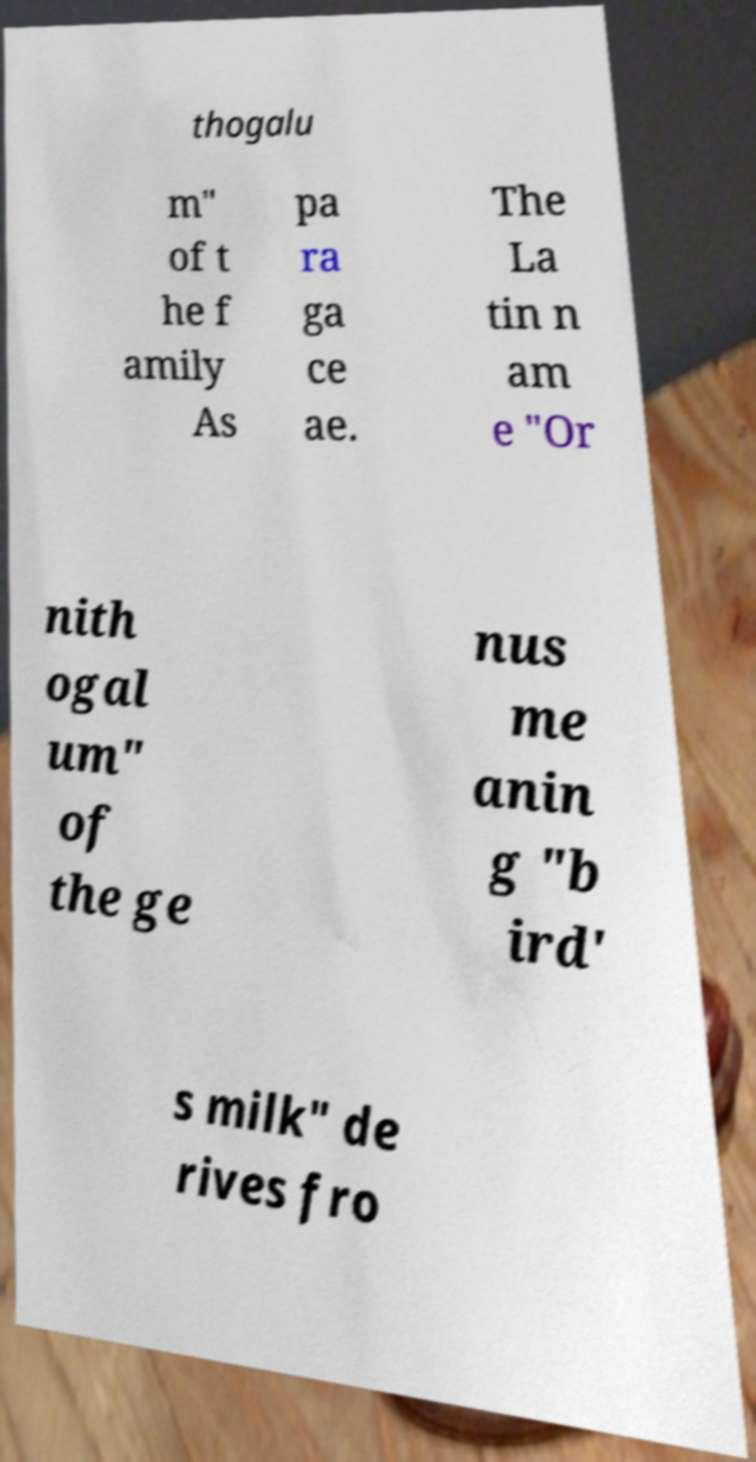Could you assist in decoding the text presented in this image and type it out clearly? thogalu m" of t he f amily As pa ra ga ce ae. The La tin n am e "Or nith ogal um" of the ge nus me anin g "b ird' s milk" de rives fro 